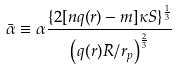Convert formula to latex. <formula><loc_0><loc_0><loc_500><loc_500>\bar { \alpha } \equiv \alpha \frac { \{ 2 [ n q ( r ) - m ] \kappa S \} ^ { \frac { 1 } { 3 } } } { { \left ( { q ( r ) R } / { r _ { p } } \right ) } ^ { \frac { 2 } { 3 } } }</formula> 